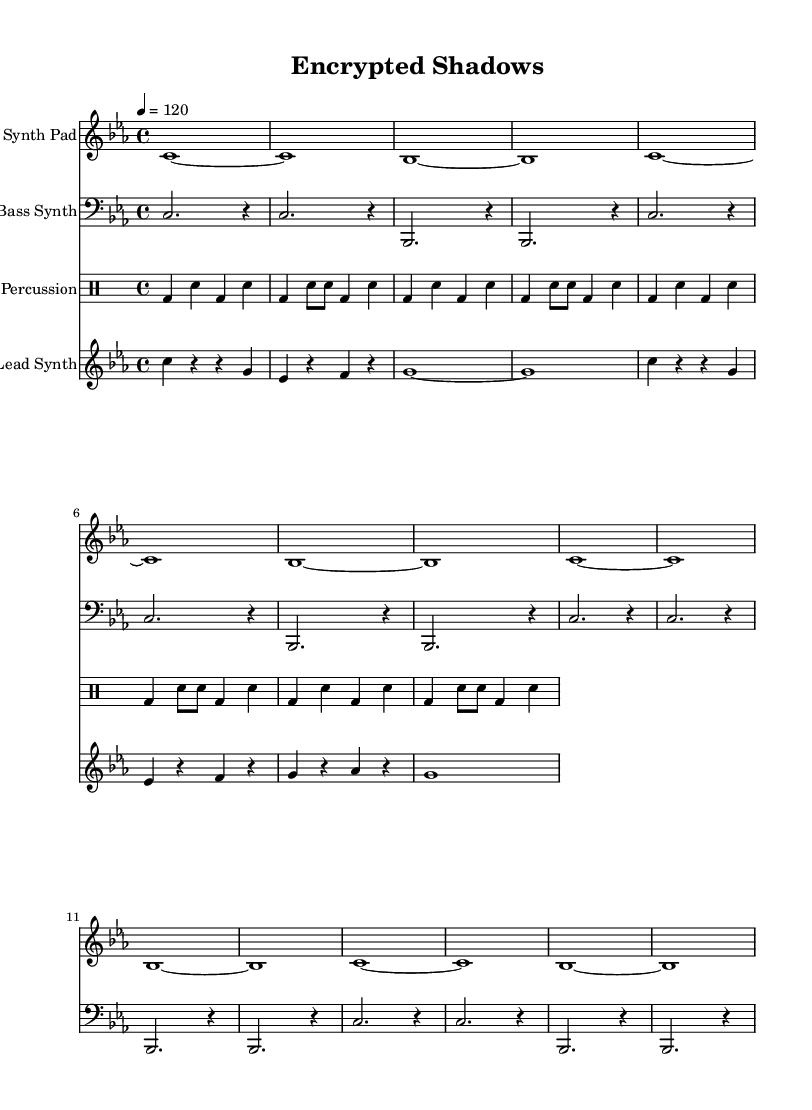What is the key signature of this music? The key signature is C minor, which has three flats (B♭, E♭, and A♭). This can be determined by identifying the key signature markings at the beginning of the staff.
Answer: C minor What is the time signature of the piece? The time signature is 4/4, which indicates that there are four beats in each measure and the quarter note gets one beat. This is stated clearly at the start of the score.
Answer: 4/4 What is the tempo marking for the music? The tempo marking is given as 120, meaning 120 beats per minute. This information is specified right above the staff in the tempo instruction.
Answer: 120 How many measures are in the "Synth Pad" part? The "Synth Pad" part has 8 measures as indicated by the repeated section and the notation lengths shown in the staff. Each repetition covers four measures, and there are two repetitions in total.
Answer: 8 What type of synthesis is primarily featured in this composition? The lead synth and bass synth are both indicative of digital synthesis, commonly used in dark ambient dance music to create atmospheric sounds. This reflects the style and production techniques characteristic of the genre.
Answer: Digital Which percussion instruments are used in the score? The score specifies bass drum and snare drum in the percussion section, indicating that these two instruments are utilized for rhythmic support. They are denoted in the drummode section of the score.
Answer: Bass drum, snare drum 